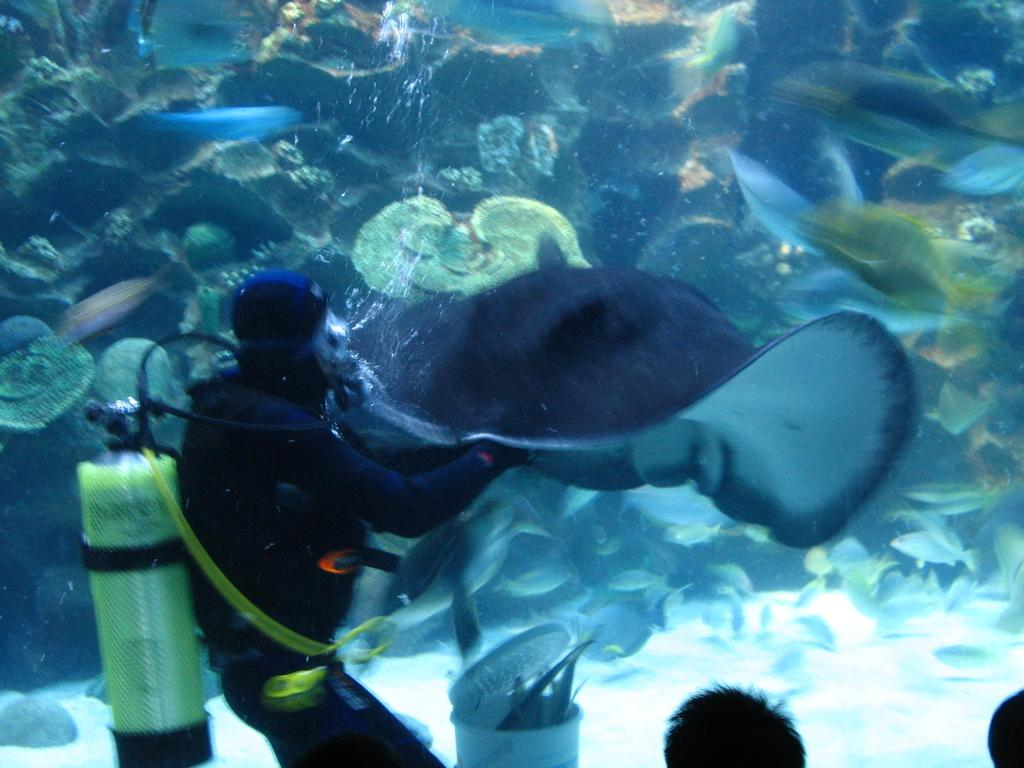What is the person in the image wearing? The person in the image is wearing a swimsuit. What can be seen in the water in the image? There is a fish and other water animals in the water in the image. How many people are visible in the image? There are two people visible in the image. What type of organization is responsible for the jam in the image? There is no jam present in the image, so it is not possible to determine which organization might be responsible for it. 